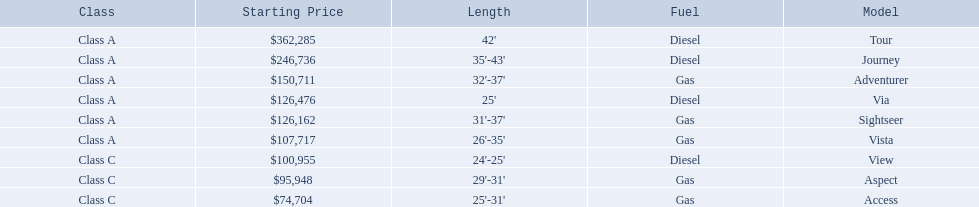What models are available from winnebago industries? Tour, Journey, Adventurer, Via, Sightseer, Vista, View, Aspect, Access. What are their starting prices? $362,285, $246,736, $150,711, $126,476, $126,162, $107,717, $100,955, $95,948, $74,704. Which model has the most costly starting price? Tour. 